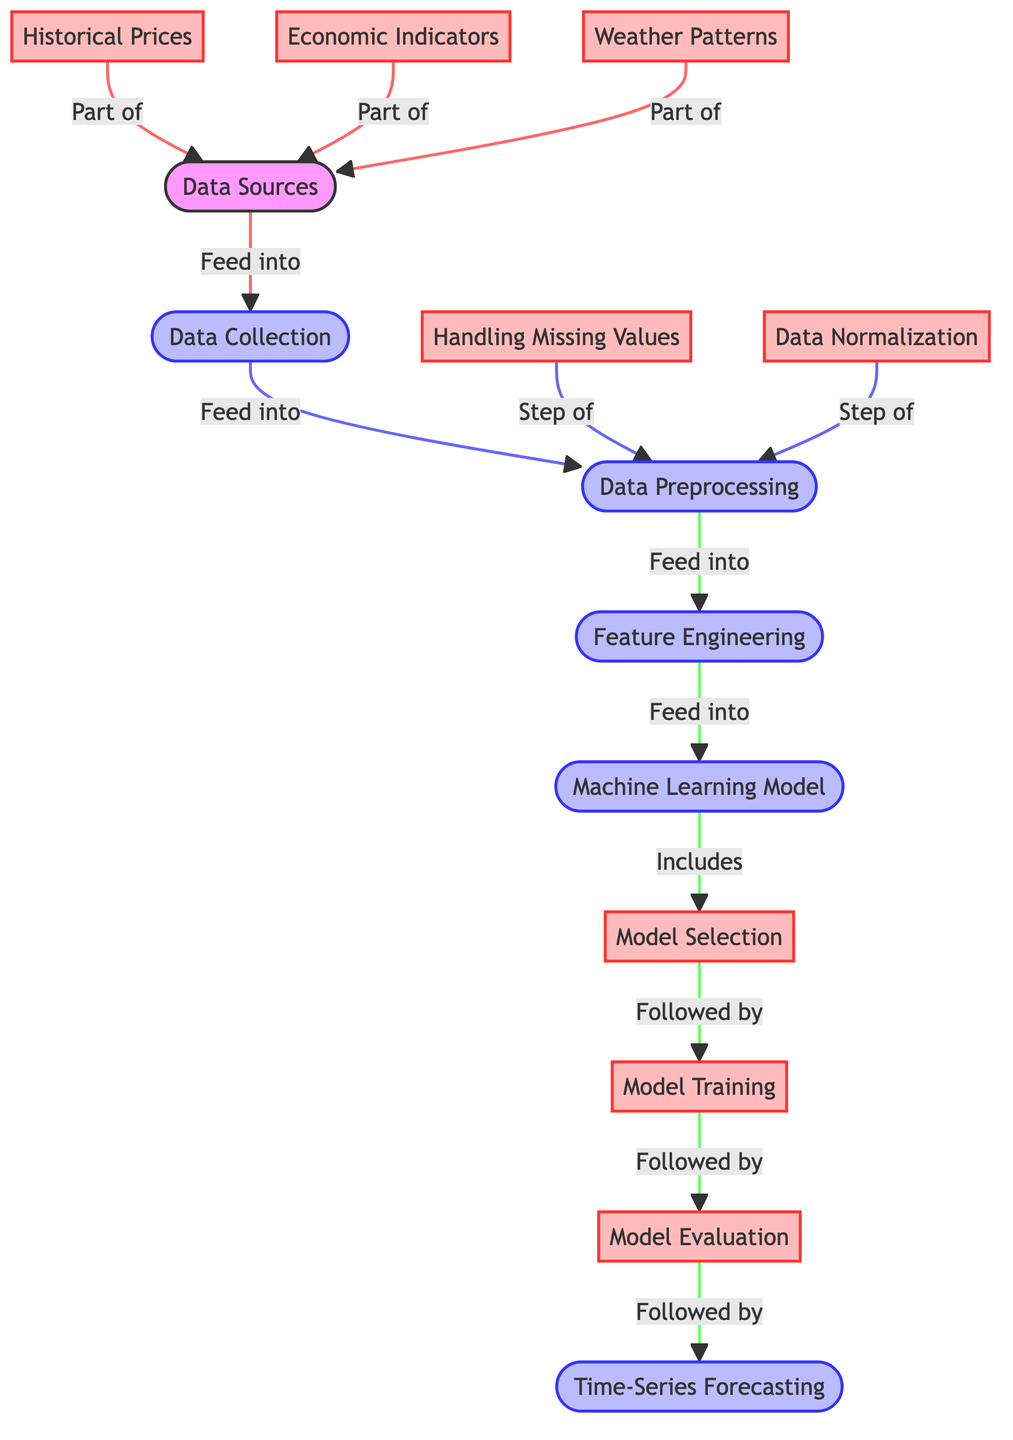What are the sources of data in this diagram? The sources of data listed in the diagram are historical prices, economic indicators, and weather patterns. These are the components that feed into the data collection process, and they are all shown as part of the data sources node.
Answer: Historical prices, economic indicators, weather patterns How many steps are involved in data preprocessing? The diagram indicates two specific steps in the data preprocessing node: handling missing values and data normalization. Thus, there are two steps that form this process before it moves to feature engineering.
Answer: Two Which node follows model selection? The diagram shows that the node that follows model selection is training. This means that after selecting the appropriate model, the next step is to train that model with the data.
Answer: Training What is the final output of the diagram process? The final output of the diagram process is time-series forecasting. This is the end result that comes after evaluating the trained model.
Answer: Time-series forecasting What is a key process step after data preprocessing? After data preprocessing, the next key process step is feature engineering, which involves preparing the data features for the machine learning model. This is crucial for building an effective prediction system.
Answer: Feature engineering What is inclusive of the machine learning model node? The machine learning model node includes model selection, indicating that the process of selecting an optimal model is part of developing the machine learning aspect in the diagram.
Answer: Model selection How does economic indicators relate to data sources? Economic indicators are categorized as a part of the data sources. This indicates that they contribute to the information needed for data collection, influencing cost forecasting.
Answer: Part of What precedes evaluation in the flow of this diagram? In the diagram's flow, training is the step that precedes evaluation. This means once the model has been trained, it will then go through an evaluation process to assess its performance.
Answer: Training Which two steps are involved in handling data normalization? The diagram lists data normalization as a step within data preprocessing, which involves adjusting the values in the dataset to a common scale without distorting differences in the ranges of values.
Answer: Part of data preprocessing 